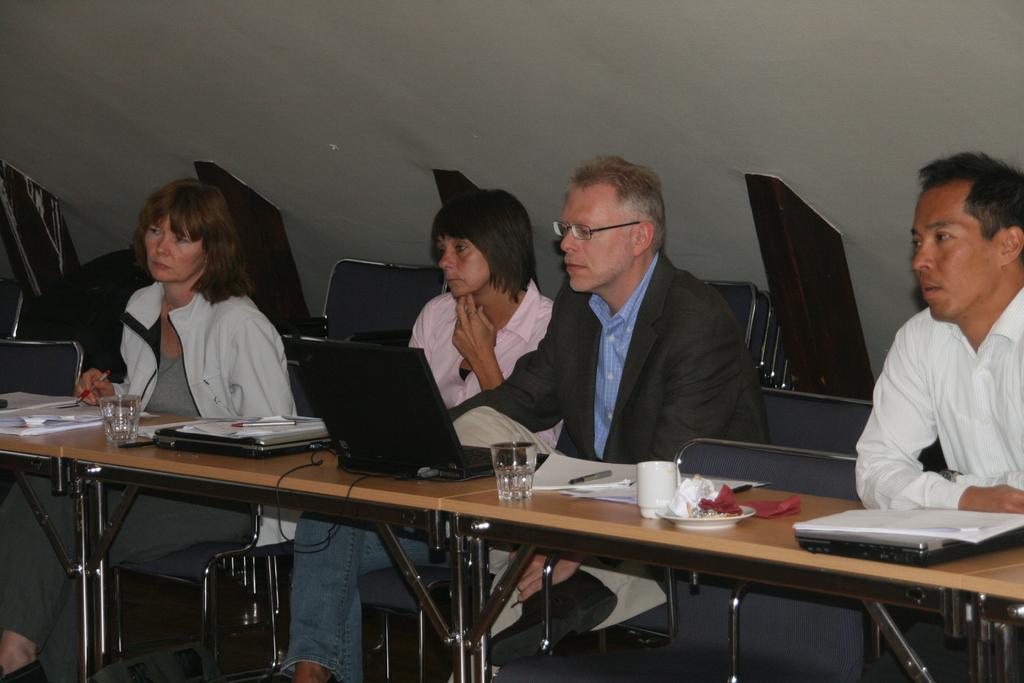Can you describe this image briefly? In this image in the center there are some people who are sitting on chairs, in front of them there is one table. On the table there are some laptops, papers, cups, glasses and some bottles and in the background there is a wall and some objects. 